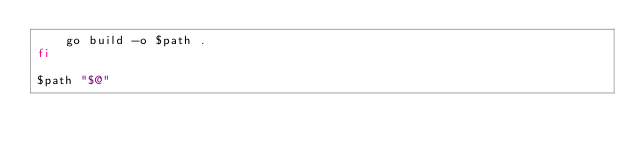<code> <loc_0><loc_0><loc_500><loc_500><_Bash_>    go build -o $path .
fi

$path "$@"
</code> 